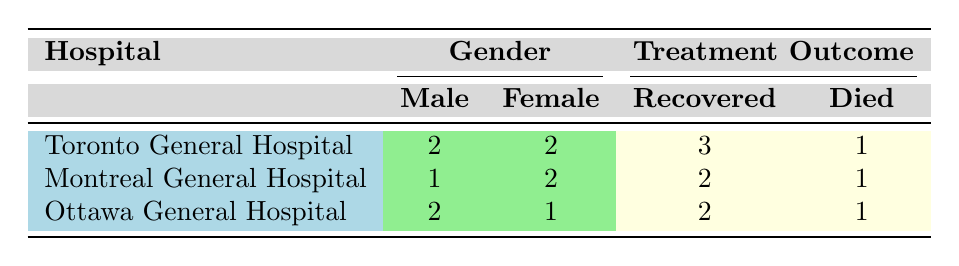What is the total number of male patients across all hospitals? By examining the male patient counts in each hospital from the table: Toronto General Hospital has 2, Montreal General Hospital has 1, and Ottawa General Hospital has 2. Thus, the total number of male patients is 2 + 1 + 2 = 5.
Answer: 5 How many female patients at Toronto General Hospital had a treatment outcome of "Recovered"? Looking at the Toronto General Hospital row, there are 2 female patients, one had "Scarlet Fever" and the other "Typhus," both of whom were noted as "Recovered." Hence, the count of female patients who recovered is 2.
Answer: 2 Did Ottawa General Hospital record any patients who died? We can see from the table that Ottawa General Hospital has 1 female patient who died from "Heart Disease." Therefore, the answer to this question is yes.
Answer: Yes What is the recovery rate for male patients in Montreal General Hospital? In Montreal General Hospital, there is 1 male patient, and he recovered from "Measles." To find the recovery rate, we compute (1 recovered male / 1 total male) * 100 = 100%.
Answer: 100% Which hospital had the highest number of total recoveries? Analyzing the recoveries: Toronto General Hospital has 3, Montreal General Hospital has 2, and Ottawa General Hospital has 2. Toronto General Hospital has the highest number of recoveries with 3.
Answer: Toronto General Hospital How many total patients died across all hospitals? We need to aggregate the number of patients who died for each hospital: Toronto General Hospital has 1, Montreal General Hospital has 1, and Ottawa General Hospital has 1. Thus, the total number of patients who died is 1 + 1 + 1 = 3.
Answer: 3 Was there any case of "Pneumonia" resulting in death in the hospitals listed? Looking through the treatment outcomes in all rows, there is one case of "Pneumonia" from Montreal General Hospital that resulted in death; no cases from Toronto General Hospital or Ottawa General Hospital had this outcome. Therefore, the answer to this question is no.
Answer: No How does the gender distribution of male patients relate to recoveries in Toronto General Hospital? In Toronto General Hospital, there are 2 male patients – both are accounted in the recoveries (one from Pneumonia). As such, all male patients there recovered, resulting in a male recovery rate of 100%.
Answer: 100% What is the ratio of male to female patients in Ottawa General Hospital? In Ottawa General Hospital, there are 2 male patients and 1 female patient. Therefore, the ratio of male to female patients is 2:1.
Answer: 2:1 